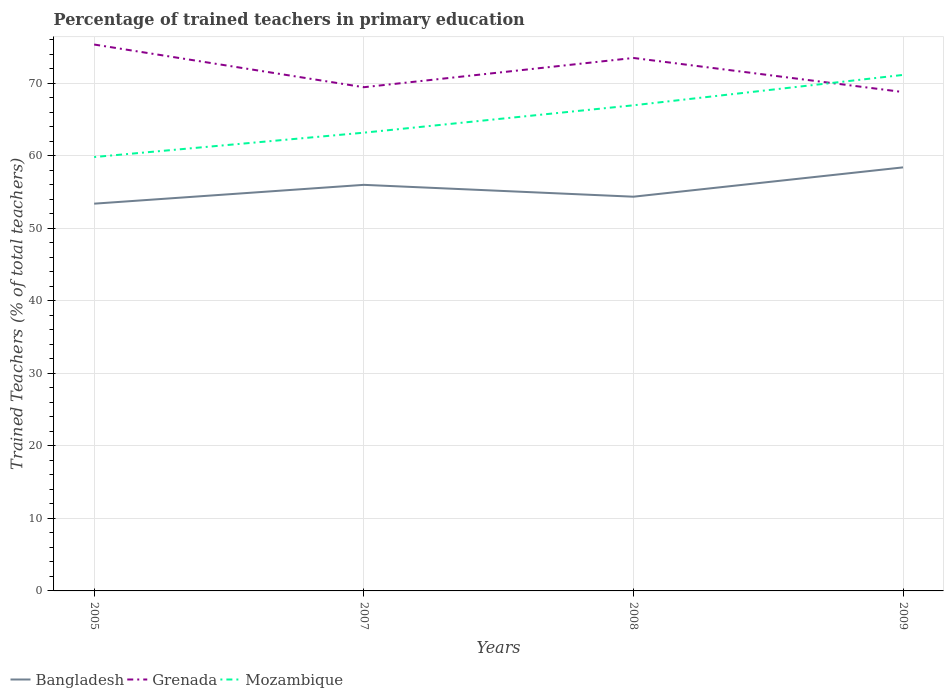Is the number of lines equal to the number of legend labels?
Give a very brief answer. Yes. Across all years, what is the maximum percentage of trained teachers in Mozambique?
Provide a succinct answer. 59.83. What is the total percentage of trained teachers in Mozambique in the graph?
Provide a succinct answer. -4.19. What is the difference between the highest and the second highest percentage of trained teachers in Mozambique?
Provide a short and direct response. 11.32. What is the difference between two consecutive major ticks on the Y-axis?
Your response must be concise. 10. Does the graph contain any zero values?
Ensure brevity in your answer.  No. How many legend labels are there?
Make the answer very short. 3. What is the title of the graph?
Provide a succinct answer. Percentage of trained teachers in primary education. What is the label or title of the Y-axis?
Give a very brief answer. Trained Teachers (% of total teachers). What is the Trained Teachers (% of total teachers) of Bangladesh in 2005?
Your answer should be compact. 53.4. What is the Trained Teachers (% of total teachers) in Grenada in 2005?
Provide a succinct answer. 75.35. What is the Trained Teachers (% of total teachers) in Mozambique in 2005?
Offer a very short reply. 59.83. What is the Trained Teachers (% of total teachers) in Bangladesh in 2007?
Provide a short and direct response. 56. What is the Trained Teachers (% of total teachers) of Grenada in 2007?
Make the answer very short. 69.46. What is the Trained Teachers (% of total teachers) of Mozambique in 2007?
Your response must be concise. 63.19. What is the Trained Teachers (% of total teachers) of Bangladesh in 2008?
Offer a very short reply. 54.36. What is the Trained Teachers (% of total teachers) in Grenada in 2008?
Offer a very short reply. 73.5. What is the Trained Teachers (% of total teachers) in Mozambique in 2008?
Offer a very short reply. 66.97. What is the Trained Teachers (% of total teachers) of Bangladesh in 2009?
Offer a very short reply. 58.41. What is the Trained Teachers (% of total teachers) of Grenada in 2009?
Offer a very short reply. 68.8. What is the Trained Teachers (% of total teachers) in Mozambique in 2009?
Your response must be concise. 71.16. Across all years, what is the maximum Trained Teachers (% of total teachers) of Bangladesh?
Provide a short and direct response. 58.41. Across all years, what is the maximum Trained Teachers (% of total teachers) in Grenada?
Offer a terse response. 75.35. Across all years, what is the maximum Trained Teachers (% of total teachers) in Mozambique?
Offer a very short reply. 71.16. Across all years, what is the minimum Trained Teachers (% of total teachers) in Bangladesh?
Make the answer very short. 53.4. Across all years, what is the minimum Trained Teachers (% of total teachers) of Grenada?
Offer a terse response. 68.8. Across all years, what is the minimum Trained Teachers (% of total teachers) in Mozambique?
Provide a succinct answer. 59.83. What is the total Trained Teachers (% of total teachers) of Bangladesh in the graph?
Provide a succinct answer. 222.17. What is the total Trained Teachers (% of total teachers) in Grenada in the graph?
Keep it short and to the point. 287.1. What is the total Trained Teachers (% of total teachers) of Mozambique in the graph?
Make the answer very short. 261.15. What is the difference between the Trained Teachers (% of total teachers) in Bangladesh in 2005 and that in 2007?
Your response must be concise. -2.6. What is the difference between the Trained Teachers (% of total teachers) in Grenada in 2005 and that in 2007?
Your answer should be very brief. 5.89. What is the difference between the Trained Teachers (% of total teachers) in Mozambique in 2005 and that in 2007?
Provide a short and direct response. -3.36. What is the difference between the Trained Teachers (% of total teachers) in Bangladesh in 2005 and that in 2008?
Offer a terse response. -0.96. What is the difference between the Trained Teachers (% of total teachers) of Grenada in 2005 and that in 2008?
Your answer should be compact. 1.85. What is the difference between the Trained Teachers (% of total teachers) of Mozambique in 2005 and that in 2008?
Offer a terse response. -7.13. What is the difference between the Trained Teachers (% of total teachers) of Bangladesh in 2005 and that in 2009?
Your answer should be compact. -5.01. What is the difference between the Trained Teachers (% of total teachers) of Grenada in 2005 and that in 2009?
Give a very brief answer. 6.55. What is the difference between the Trained Teachers (% of total teachers) of Mozambique in 2005 and that in 2009?
Your response must be concise. -11.32. What is the difference between the Trained Teachers (% of total teachers) in Bangladesh in 2007 and that in 2008?
Ensure brevity in your answer.  1.64. What is the difference between the Trained Teachers (% of total teachers) in Grenada in 2007 and that in 2008?
Ensure brevity in your answer.  -4.04. What is the difference between the Trained Teachers (% of total teachers) of Mozambique in 2007 and that in 2008?
Offer a very short reply. -3.78. What is the difference between the Trained Teachers (% of total teachers) in Bangladesh in 2007 and that in 2009?
Your response must be concise. -2.41. What is the difference between the Trained Teachers (% of total teachers) in Grenada in 2007 and that in 2009?
Your answer should be compact. 0.67. What is the difference between the Trained Teachers (% of total teachers) of Mozambique in 2007 and that in 2009?
Give a very brief answer. -7.97. What is the difference between the Trained Teachers (% of total teachers) in Bangladesh in 2008 and that in 2009?
Give a very brief answer. -4.04. What is the difference between the Trained Teachers (% of total teachers) in Grenada in 2008 and that in 2009?
Keep it short and to the point. 4.7. What is the difference between the Trained Teachers (% of total teachers) of Mozambique in 2008 and that in 2009?
Your answer should be compact. -4.19. What is the difference between the Trained Teachers (% of total teachers) in Bangladesh in 2005 and the Trained Teachers (% of total teachers) in Grenada in 2007?
Keep it short and to the point. -16.06. What is the difference between the Trained Teachers (% of total teachers) of Bangladesh in 2005 and the Trained Teachers (% of total teachers) of Mozambique in 2007?
Your answer should be compact. -9.79. What is the difference between the Trained Teachers (% of total teachers) in Grenada in 2005 and the Trained Teachers (% of total teachers) in Mozambique in 2007?
Your answer should be very brief. 12.16. What is the difference between the Trained Teachers (% of total teachers) of Bangladesh in 2005 and the Trained Teachers (% of total teachers) of Grenada in 2008?
Make the answer very short. -20.09. What is the difference between the Trained Teachers (% of total teachers) in Bangladesh in 2005 and the Trained Teachers (% of total teachers) in Mozambique in 2008?
Make the answer very short. -13.57. What is the difference between the Trained Teachers (% of total teachers) in Grenada in 2005 and the Trained Teachers (% of total teachers) in Mozambique in 2008?
Offer a terse response. 8.38. What is the difference between the Trained Teachers (% of total teachers) in Bangladesh in 2005 and the Trained Teachers (% of total teachers) in Grenada in 2009?
Make the answer very short. -15.39. What is the difference between the Trained Teachers (% of total teachers) in Bangladesh in 2005 and the Trained Teachers (% of total teachers) in Mozambique in 2009?
Keep it short and to the point. -17.76. What is the difference between the Trained Teachers (% of total teachers) of Grenada in 2005 and the Trained Teachers (% of total teachers) of Mozambique in 2009?
Provide a short and direct response. 4.19. What is the difference between the Trained Teachers (% of total teachers) of Bangladesh in 2007 and the Trained Teachers (% of total teachers) of Grenada in 2008?
Provide a short and direct response. -17.5. What is the difference between the Trained Teachers (% of total teachers) in Bangladesh in 2007 and the Trained Teachers (% of total teachers) in Mozambique in 2008?
Offer a terse response. -10.97. What is the difference between the Trained Teachers (% of total teachers) of Grenada in 2007 and the Trained Teachers (% of total teachers) of Mozambique in 2008?
Offer a very short reply. 2.49. What is the difference between the Trained Teachers (% of total teachers) in Bangladesh in 2007 and the Trained Teachers (% of total teachers) in Grenada in 2009?
Offer a very short reply. -12.8. What is the difference between the Trained Teachers (% of total teachers) in Bangladesh in 2007 and the Trained Teachers (% of total teachers) in Mozambique in 2009?
Your response must be concise. -15.16. What is the difference between the Trained Teachers (% of total teachers) of Grenada in 2007 and the Trained Teachers (% of total teachers) of Mozambique in 2009?
Provide a short and direct response. -1.7. What is the difference between the Trained Teachers (% of total teachers) of Bangladesh in 2008 and the Trained Teachers (% of total teachers) of Grenada in 2009?
Provide a succinct answer. -14.43. What is the difference between the Trained Teachers (% of total teachers) in Bangladesh in 2008 and the Trained Teachers (% of total teachers) in Mozambique in 2009?
Offer a terse response. -16.79. What is the difference between the Trained Teachers (% of total teachers) in Grenada in 2008 and the Trained Teachers (% of total teachers) in Mozambique in 2009?
Your answer should be compact. 2.34. What is the average Trained Teachers (% of total teachers) of Bangladesh per year?
Provide a short and direct response. 55.54. What is the average Trained Teachers (% of total teachers) of Grenada per year?
Your response must be concise. 71.77. What is the average Trained Teachers (% of total teachers) in Mozambique per year?
Your response must be concise. 65.29. In the year 2005, what is the difference between the Trained Teachers (% of total teachers) in Bangladesh and Trained Teachers (% of total teachers) in Grenada?
Ensure brevity in your answer.  -21.95. In the year 2005, what is the difference between the Trained Teachers (% of total teachers) in Bangladesh and Trained Teachers (% of total teachers) in Mozambique?
Make the answer very short. -6.43. In the year 2005, what is the difference between the Trained Teachers (% of total teachers) of Grenada and Trained Teachers (% of total teachers) of Mozambique?
Give a very brief answer. 15.51. In the year 2007, what is the difference between the Trained Teachers (% of total teachers) of Bangladesh and Trained Teachers (% of total teachers) of Grenada?
Your response must be concise. -13.46. In the year 2007, what is the difference between the Trained Teachers (% of total teachers) in Bangladesh and Trained Teachers (% of total teachers) in Mozambique?
Give a very brief answer. -7.19. In the year 2007, what is the difference between the Trained Teachers (% of total teachers) in Grenada and Trained Teachers (% of total teachers) in Mozambique?
Your answer should be compact. 6.27. In the year 2008, what is the difference between the Trained Teachers (% of total teachers) in Bangladesh and Trained Teachers (% of total teachers) in Grenada?
Give a very brief answer. -19.13. In the year 2008, what is the difference between the Trained Teachers (% of total teachers) in Bangladesh and Trained Teachers (% of total teachers) in Mozambique?
Ensure brevity in your answer.  -12.6. In the year 2008, what is the difference between the Trained Teachers (% of total teachers) of Grenada and Trained Teachers (% of total teachers) of Mozambique?
Provide a succinct answer. 6.53. In the year 2009, what is the difference between the Trained Teachers (% of total teachers) of Bangladesh and Trained Teachers (% of total teachers) of Grenada?
Offer a very short reply. -10.39. In the year 2009, what is the difference between the Trained Teachers (% of total teachers) in Bangladesh and Trained Teachers (% of total teachers) in Mozambique?
Your answer should be compact. -12.75. In the year 2009, what is the difference between the Trained Teachers (% of total teachers) in Grenada and Trained Teachers (% of total teachers) in Mozambique?
Your answer should be very brief. -2.36. What is the ratio of the Trained Teachers (% of total teachers) of Bangladesh in 2005 to that in 2007?
Offer a terse response. 0.95. What is the ratio of the Trained Teachers (% of total teachers) of Grenada in 2005 to that in 2007?
Your response must be concise. 1.08. What is the ratio of the Trained Teachers (% of total teachers) in Mozambique in 2005 to that in 2007?
Your answer should be very brief. 0.95. What is the ratio of the Trained Teachers (% of total teachers) of Bangladesh in 2005 to that in 2008?
Ensure brevity in your answer.  0.98. What is the ratio of the Trained Teachers (% of total teachers) in Grenada in 2005 to that in 2008?
Your response must be concise. 1.03. What is the ratio of the Trained Teachers (% of total teachers) in Mozambique in 2005 to that in 2008?
Offer a terse response. 0.89. What is the ratio of the Trained Teachers (% of total teachers) of Bangladesh in 2005 to that in 2009?
Offer a terse response. 0.91. What is the ratio of the Trained Teachers (% of total teachers) in Grenada in 2005 to that in 2009?
Give a very brief answer. 1.1. What is the ratio of the Trained Teachers (% of total teachers) of Mozambique in 2005 to that in 2009?
Your answer should be compact. 0.84. What is the ratio of the Trained Teachers (% of total teachers) of Bangladesh in 2007 to that in 2008?
Your response must be concise. 1.03. What is the ratio of the Trained Teachers (% of total teachers) of Grenada in 2007 to that in 2008?
Provide a succinct answer. 0.95. What is the ratio of the Trained Teachers (% of total teachers) in Mozambique in 2007 to that in 2008?
Your answer should be compact. 0.94. What is the ratio of the Trained Teachers (% of total teachers) in Bangladesh in 2007 to that in 2009?
Your answer should be compact. 0.96. What is the ratio of the Trained Teachers (% of total teachers) in Grenada in 2007 to that in 2009?
Give a very brief answer. 1.01. What is the ratio of the Trained Teachers (% of total teachers) of Mozambique in 2007 to that in 2009?
Provide a short and direct response. 0.89. What is the ratio of the Trained Teachers (% of total teachers) of Bangladesh in 2008 to that in 2009?
Your response must be concise. 0.93. What is the ratio of the Trained Teachers (% of total teachers) in Grenada in 2008 to that in 2009?
Offer a terse response. 1.07. What is the ratio of the Trained Teachers (% of total teachers) in Mozambique in 2008 to that in 2009?
Ensure brevity in your answer.  0.94. What is the difference between the highest and the second highest Trained Teachers (% of total teachers) of Bangladesh?
Provide a short and direct response. 2.41. What is the difference between the highest and the second highest Trained Teachers (% of total teachers) in Grenada?
Your answer should be compact. 1.85. What is the difference between the highest and the second highest Trained Teachers (% of total teachers) in Mozambique?
Offer a terse response. 4.19. What is the difference between the highest and the lowest Trained Teachers (% of total teachers) of Bangladesh?
Your answer should be very brief. 5.01. What is the difference between the highest and the lowest Trained Teachers (% of total teachers) of Grenada?
Give a very brief answer. 6.55. What is the difference between the highest and the lowest Trained Teachers (% of total teachers) in Mozambique?
Offer a terse response. 11.32. 